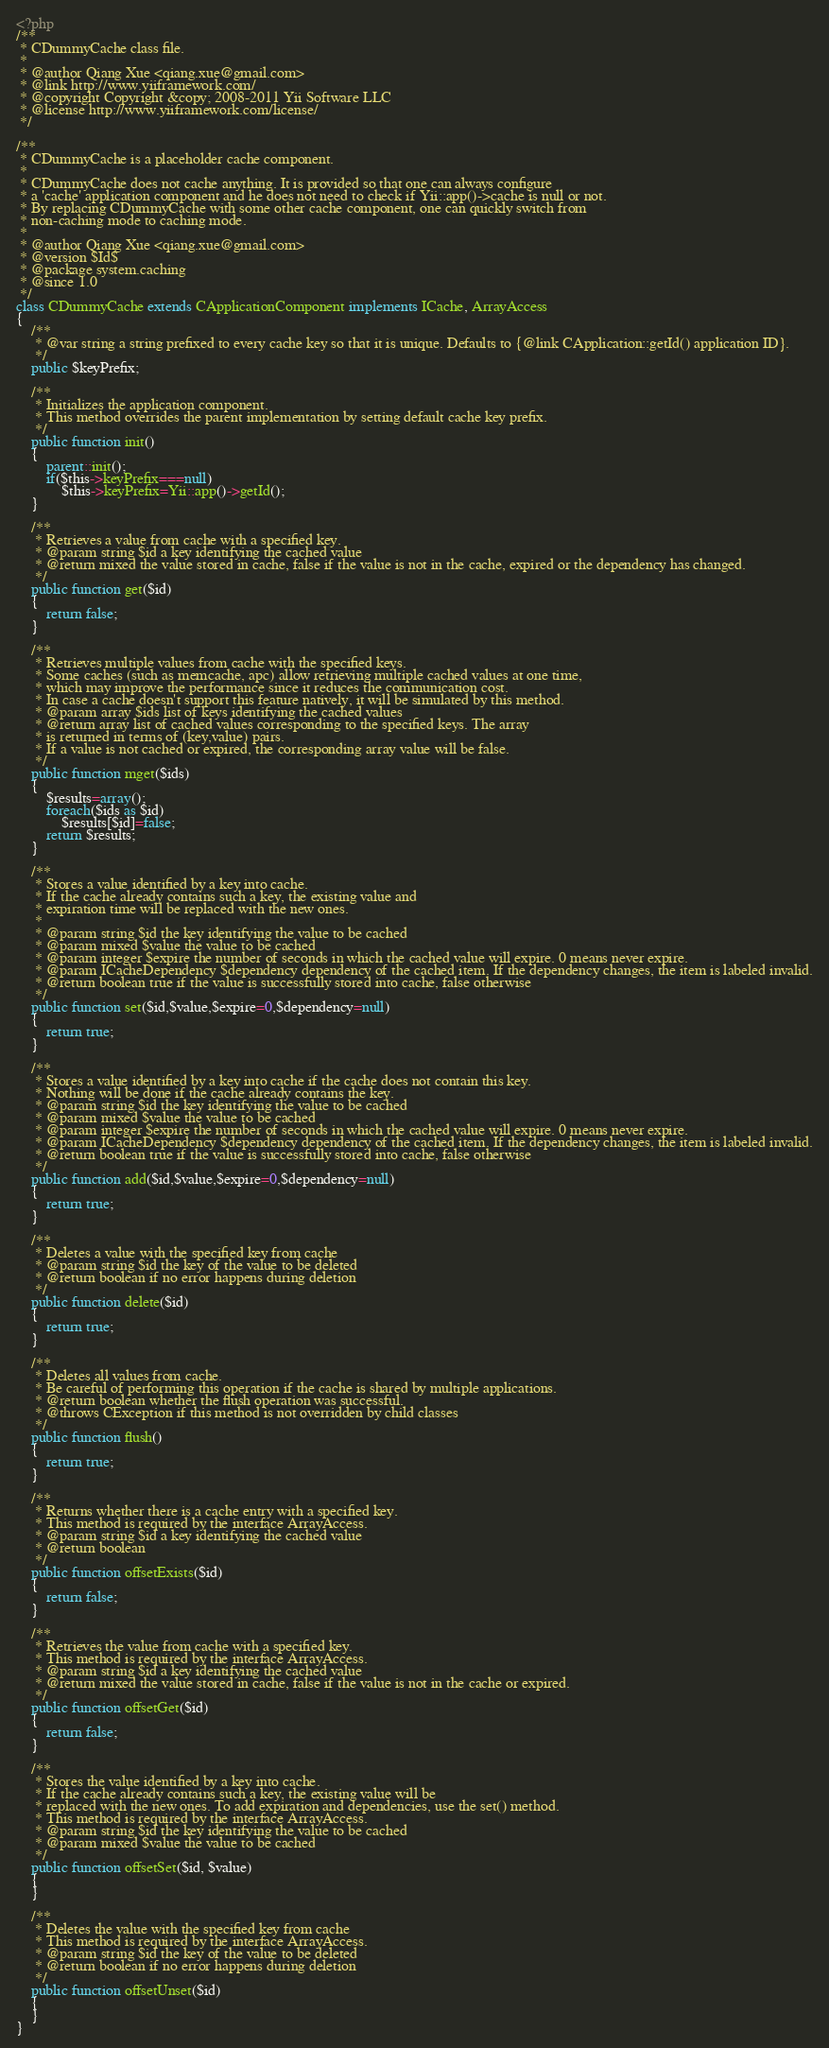Convert code to text. <code><loc_0><loc_0><loc_500><loc_500><_PHP_><?php
/**
 * CDummyCache class file.
 *
 * @author Qiang Xue <qiang.xue@gmail.com>
 * @link http://www.yiiframework.com/
 * @copyright Copyright &copy; 2008-2011 Yii Software LLC
 * @license http://www.yiiframework.com/license/
 */

/**
 * CDummyCache is a placeholder cache component.
 *
 * CDummyCache does not cache anything. It is provided so that one can always configure
 * a 'cache' application component and he does not need to check if Yii::app()->cache is null or not.
 * By replacing CDummyCache with some other cache component, one can quickly switch from
 * non-caching mode to caching mode.
 *
 * @author Qiang Xue <qiang.xue@gmail.com>
 * @version $Id$
 * @package system.caching
 * @since 1.0
 */
class CDummyCache extends CApplicationComponent implements ICache, ArrayAccess
{
	/**
	 * @var string a string prefixed to every cache key so that it is unique. Defaults to {@link CApplication::getId() application ID}.
	 */
	public $keyPrefix;

	/**
	 * Initializes the application component.
	 * This method overrides the parent implementation by setting default cache key prefix.
	 */
	public function init()
	{
		parent::init();
		if($this->keyPrefix===null)
			$this->keyPrefix=Yii::app()->getId();
	}

	/**
	 * Retrieves a value from cache with a specified key.
	 * @param string $id a key identifying the cached value
	 * @return mixed the value stored in cache, false if the value is not in the cache, expired or the dependency has changed.
	 */
	public function get($id)
	{
		return false;
	}

	/**
	 * Retrieves multiple values from cache with the specified keys.
	 * Some caches (such as memcache, apc) allow retrieving multiple cached values at one time,
	 * which may improve the performance since it reduces the communication cost.
	 * In case a cache doesn't support this feature natively, it will be simulated by this method.
	 * @param array $ids list of keys identifying the cached values
	 * @return array list of cached values corresponding to the specified keys. The array
	 * is returned in terms of (key,value) pairs.
	 * If a value is not cached or expired, the corresponding array value will be false.
	 */
	public function mget($ids)
	{
		$results=array();
		foreach($ids as $id)
			$results[$id]=false;
		return $results;
	}

	/**
	 * Stores a value identified by a key into cache.
	 * If the cache already contains such a key, the existing value and
	 * expiration time will be replaced with the new ones.
	 *
	 * @param string $id the key identifying the value to be cached
	 * @param mixed $value the value to be cached
	 * @param integer $expire the number of seconds in which the cached value will expire. 0 means never expire.
	 * @param ICacheDependency $dependency dependency of the cached item. If the dependency changes, the item is labeled invalid.
	 * @return boolean true if the value is successfully stored into cache, false otherwise
	 */
	public function set($id,$value,$expire=0,$dependency=null)
	{
		return true;
	}

	/**
	 * Stores a value identified by a key into cache if the cache does not contain this key.
	 * Nothing will be done if the cache already contains the key.
	 * @param string $id the key identifying the value to be cached
	 * @param mixed $value the value to be cached
	 * @param integer $expire the number of seconds in which the cached value will expire. 0 means never expire.
	 * @param ICacheDependency $dependency dependency of the cached item. If the dependency changes, the item is labeled invalid.
	 * @return boolean true if the value is successfully stored into cache, false otherwise
	 */
	public function add($id,$value,$expire=0,$dependency=null)
	{
		return true;
	}

	/**
	 * Deletes a value with the specified key from cache
	 * @param string $id the key of the value to be deleted
	 * @return boolean if no error happens during deletion
	 */
	public function delete($id)
	{
		return true;
	}

	/**
	 * Deletes all values from cache.
	 * Be careful of performing this operation if the cache is shared by multiple applications.
	 * @return boolean whether the flush operation was successful.
	 * @throws CException if this method is not overridden by child classes
	 */
	public function flush()
	{
		return true;
	}

	/**
	 * Returns whether there is a cache entry with a specified key.
	 * This method is required by the interface ArrayAccess.
	 * @param string $id a key identifying the cached value
	 * @return boolean
	 */
	public function offsetExists($id)
	{
		return false;
	}

	/**
	 * Retrieves the value from cache with a specified key.
	 * This method is required by the interface ArrayAccess.
	 * @param string $id a key identifying the cached value
	 * @return mixed the value stored in cache, false if the value is not in the cache or expired.
	 */
	public function offsetGet($id)
	{
		return false;
	}

	/**
	 * Stores the value identified by a key into cache.
	 * If the cache already contains such a key, the existing value will be
	 * replaced with the new ones. To add expiration and dependencies, use the set() method.
	 * This method is required by the interface ArrayAccess.
	 * @param string $id the key identifying the value to be cached
	 * @param mixed $value the value to be cached
	 */
	public function offsetSet($id, $value)
	{
	}

	/**
	 * Deletes the value with the specified key from cache
	 * This method is required by the interface ArrayAccess.
	 * @param string $id the key of the value to be deleted
	 * @return boolean if no error happens during deletion
	 */
	public function offsetUnset($id)
	{
	}
}
</code> 